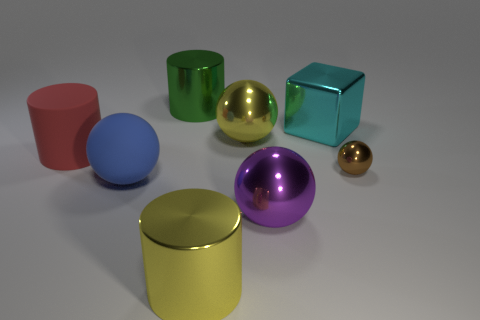Add 1 large rubber objects. How many objects exist? 9 Subtract all cubes. How many objects are left? 7 Subtract 1 purple spheres. How many objects are left? 7 Subtract all large yellow metallic cubes. Subtract all large purple balls. How many objects are left? 7 Add 3 large cyan metallic things. How many large cyan metallic things are left? 4 Add 6 small brown spheres. How many small brown spheres exist? 7 